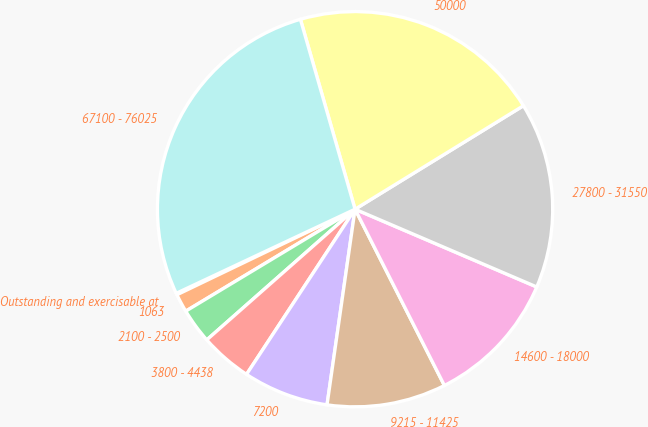Convert chart to OTSL. <chart><loc_0><loc_0><loc_500><loc_500><pie_chart><fcel>Outstanding and exercisable at<fcel>1063<fcel>2100 - 2500<fcel>3800 - 4438<fcel>7200<fcel>9215 - 11425<fcel>14600 - 18000<fcel>27800 - 31550<fcel>50000<fcel>67100 - 76025<nl><fcel>0.13%<fcel>1.5%<fcel>2.87%<fcel>4.25%<fcel>6.99%<fcel>9.73%<fcel>11.1%<fcel>15.21%<fcel>20.69%<fcel>27.54%<nl></chart> 